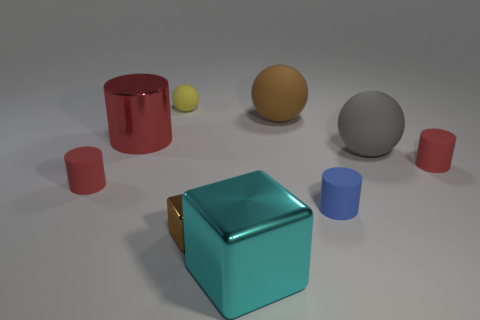Does the lighting in the scene suggest a specific time of day or lighting condition? The lighting in the scene is soft and diffused, with no harsh shadows or highlights, which implies an indoor setting with controlled lighting conditions. There are no indications of natural light sources such as windows, so it's challenging to infer a specific time of day. The even lighting suggests a photographic or studio environment where the light is deliberately arranged to minimize shadows and evenly illuminate the objects in the scene. 